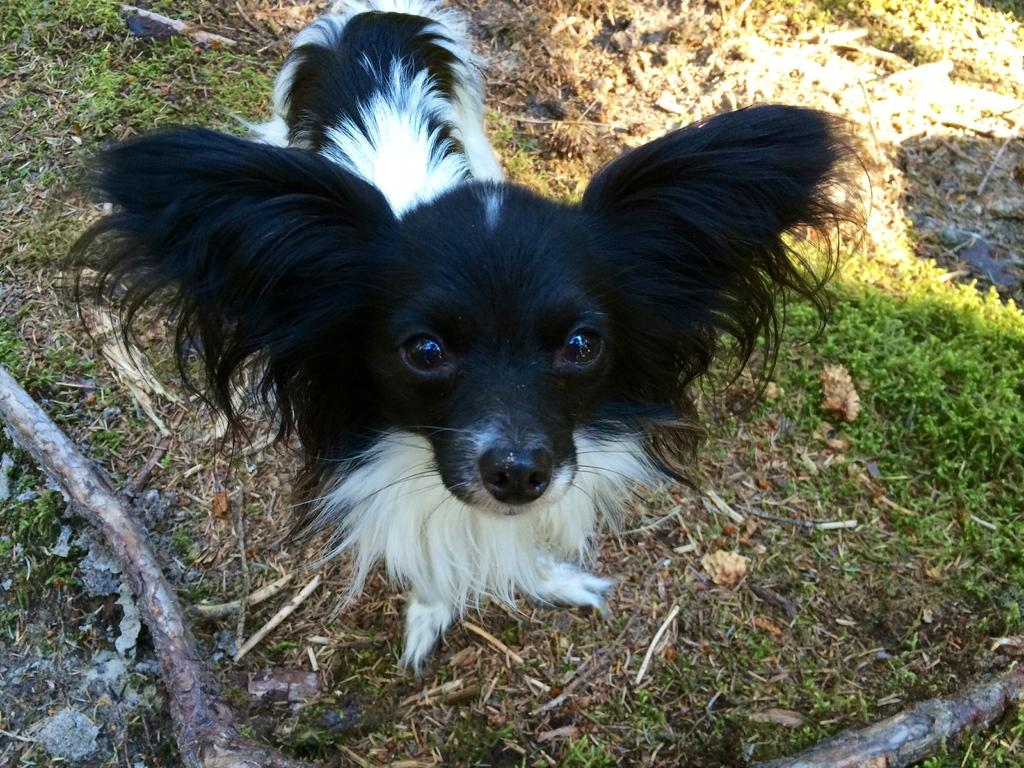What type of animal is present in the image? There is a dog in the image. What is the background of the image? There is grass behind the dog in the image. How many giants can be seen interacting with the dog in the image? There are no giants present in the image; it features a dog and grass. What park is the dog playing in, as seen in the image? The image does not specify a park; it only shows a dog and grass. 